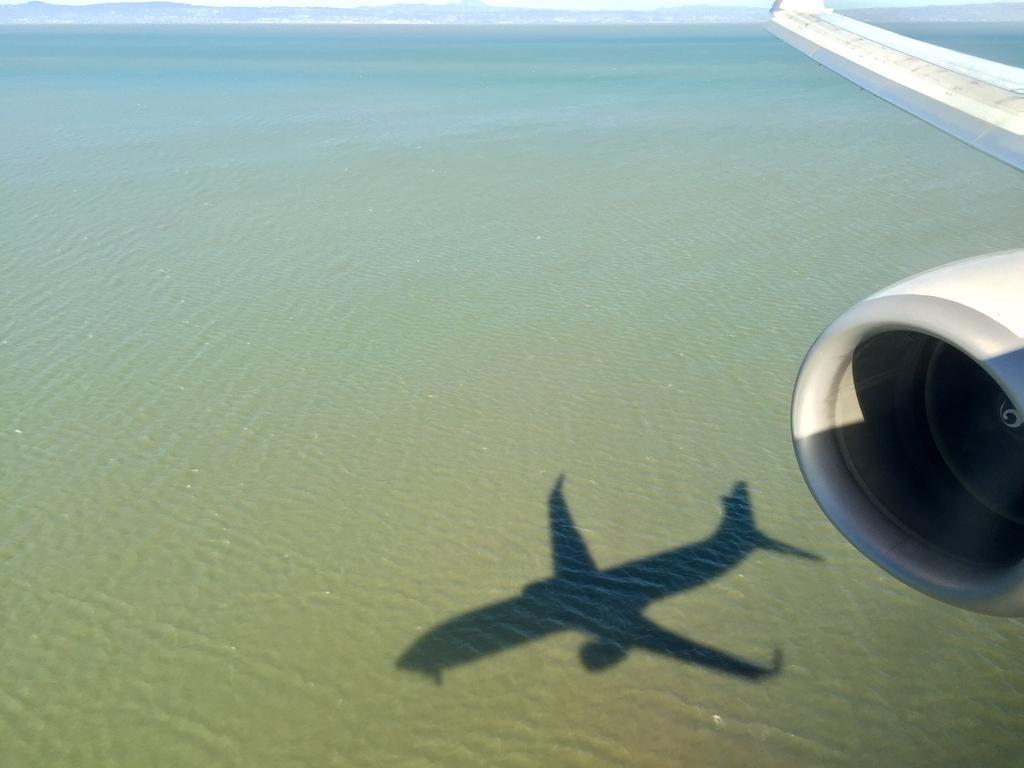In one or two sentences, can you explain what this image depicts? At the bottom of the image we can see water. In the top right corner of the image we can see a plane wing. In the water we can see a shadow of a plane. At the top of the image we can see some hills and sky. 